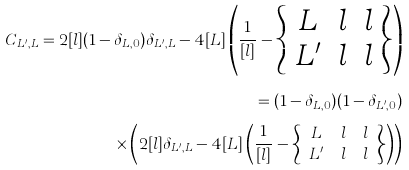Convert formula to latex. <formula><loc_0><loc_0><loc_500><loc_500>C _ { L ^ { \prime } , L } = 2 [ l ] ( 1 - \delta _ { L , 0 } ) \delta _ { L ^ { \prime } , L } - 4 [ L ] \left ( \frac { 1 } { [ l ] } - \left \{ \begin{array} { c c c } L & l & l \\ L ^ { \prime } & l & l \end{array} \right \} \right ) \\ = ( 1 - \delta _ { L , 0 } ) ( 1 - \delta _ { L ^ { \prime } , 0 } ) \\ \times \left ( 2 [ l ] \delta _ { L ^ { \prime } , L } - 4 [ L ] \left ( \frac { 1 } { [ l ] } - \left \{ \begin{array} { c c c } L & l & l \\ L ^ { \prime } & l & l \end{array} \right \} \right ) \right )</formula> 